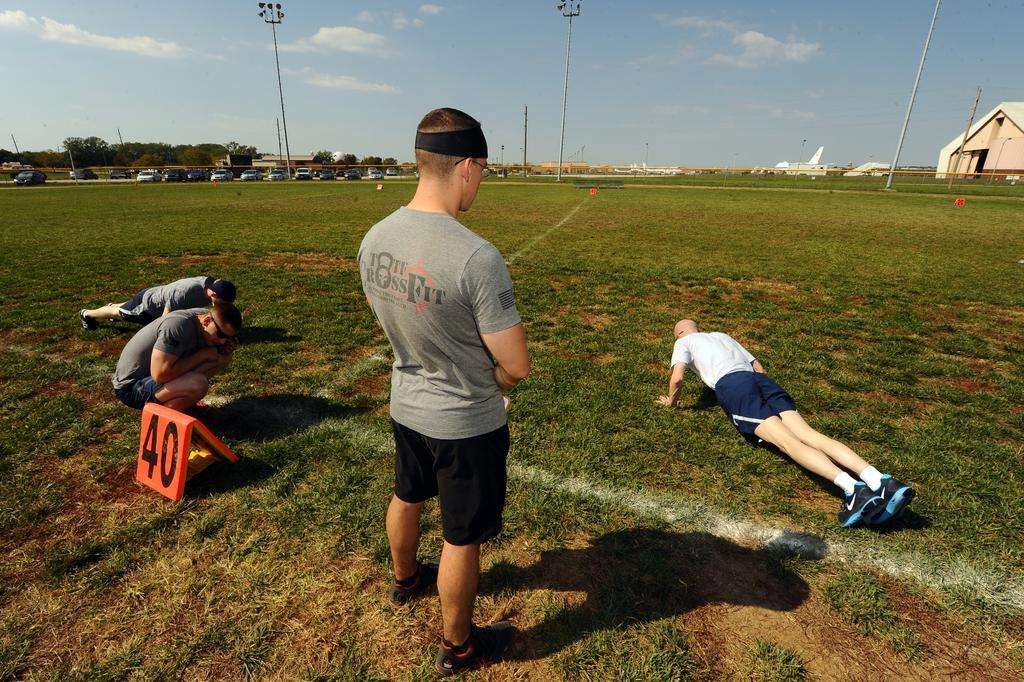Describe this image in one or two sentences. In this image, we can see some grass. There are persons in the middle of the image wearing clothes. There are poles at the top of the image. There are cars on the left side of the image. There is a shed on the right side of the image. There are clouds in the sky. 